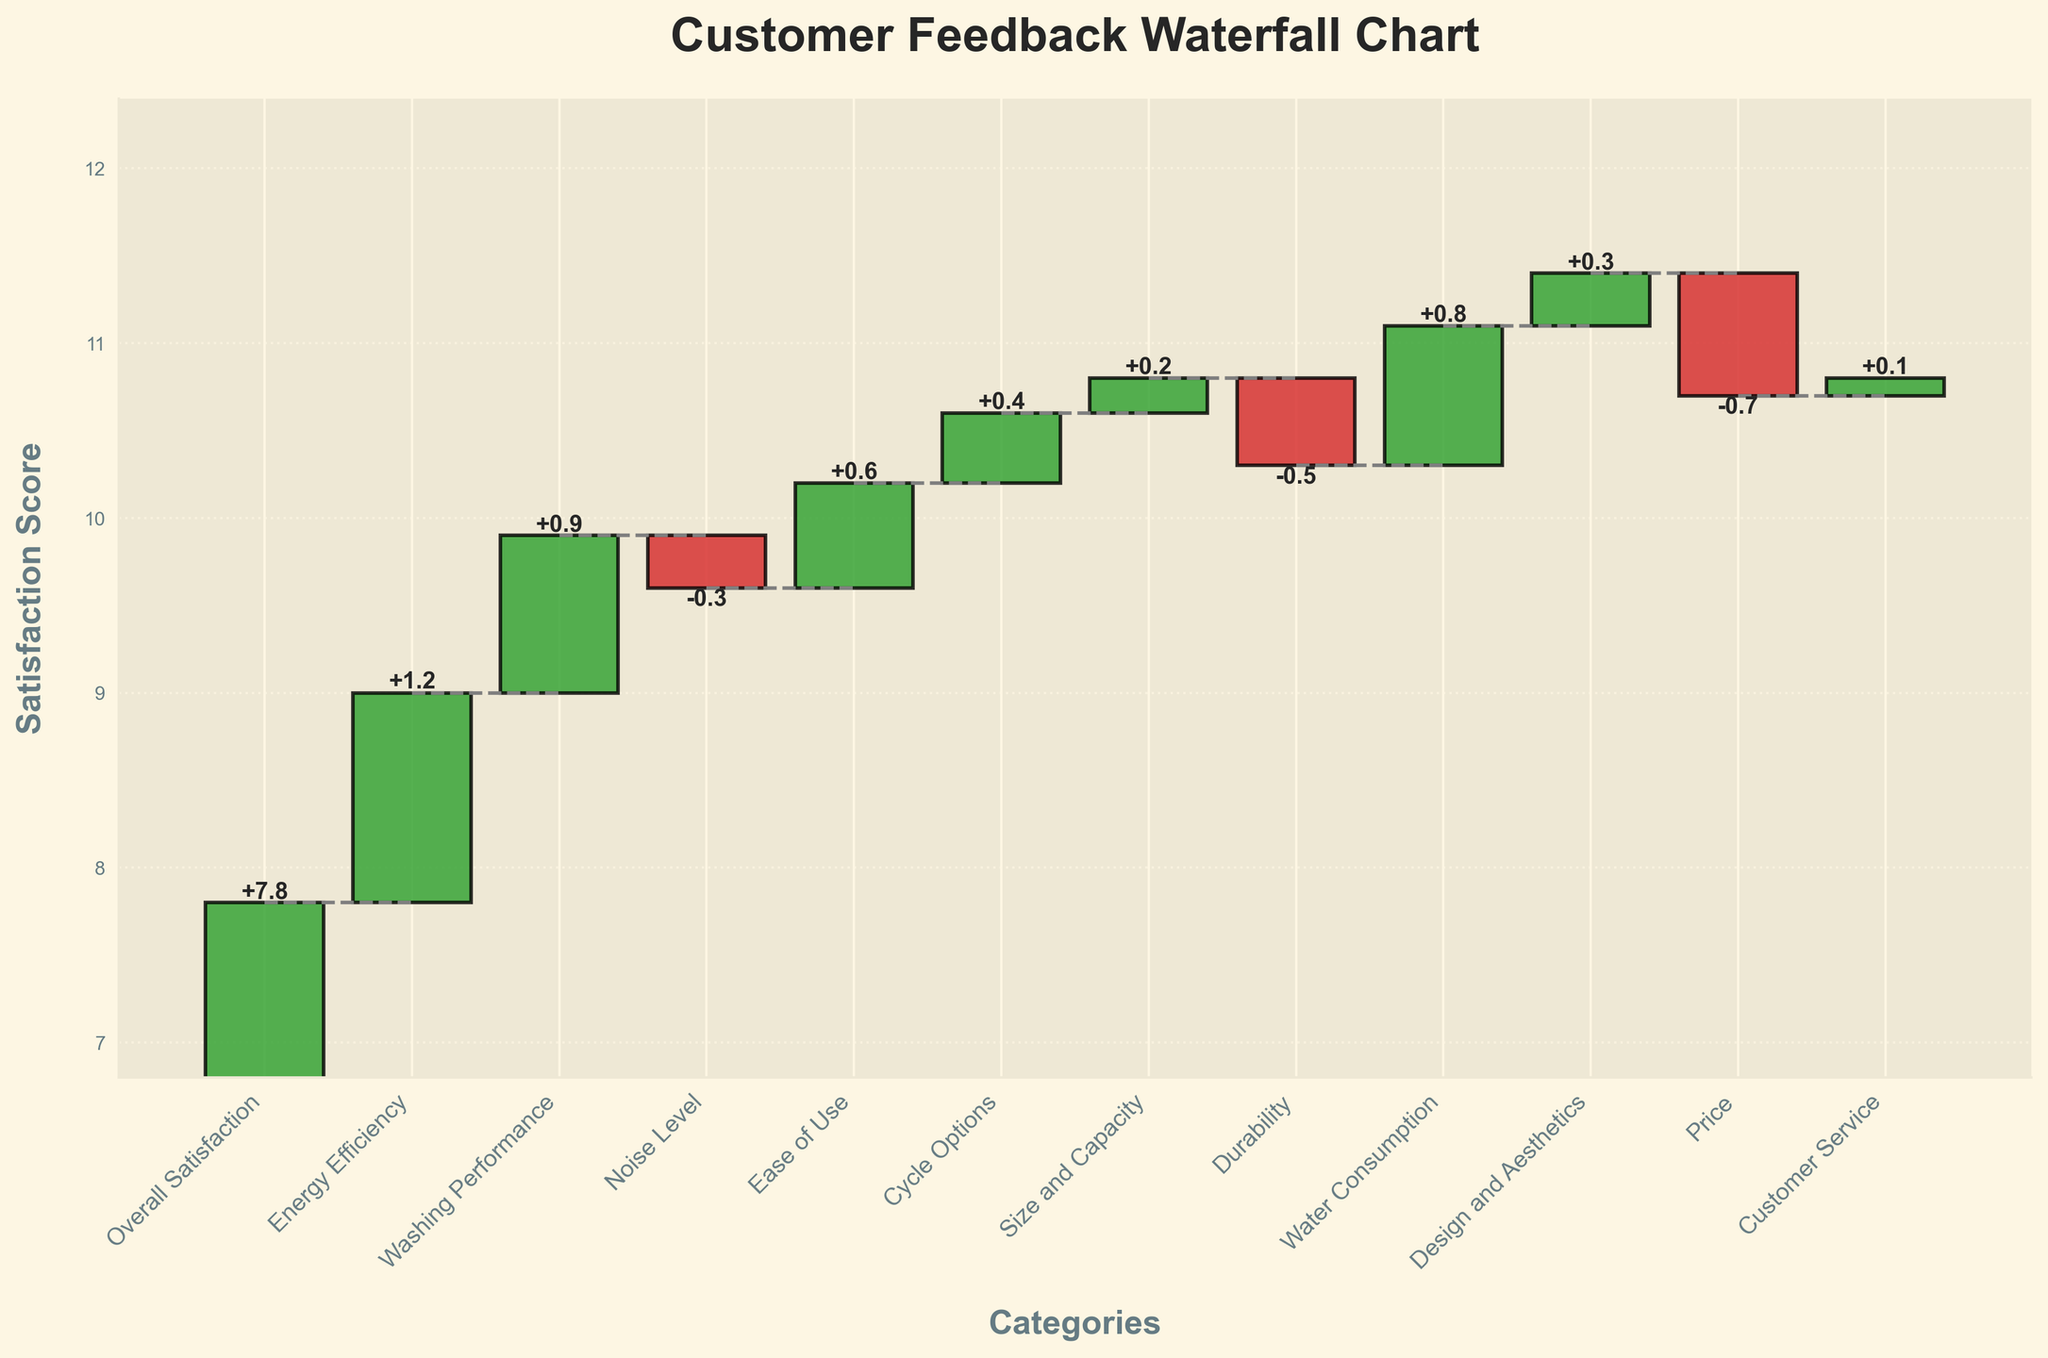What is the title of the chart? The title of the chart is prominently displayed at the top and reads "Customer Feedback Waterfall Chart".
Answer: Customer Feedback Waterfall Chart Which category has the highest positive contribution to overall satisfaction? In the chart, the bar with the highest positive value is the one corresponding to "Energy Efficiency".
Answer: Energy Efficiency Which category negatively impacts the overall satisfaction the most? The category with the longest negative bar, indicating the largest negative impact, is "Price".
Answer: Price How does the "Noise Level" category affect the overall satisfaction score? The bar for "Noise Level" is below the x-axis, which means it has a negative contribution to the overall satisfaction score.
Answer: It negatively affects the score What is the final cumulative satisfaction score after adding all the categories? The cumulative satisfaction score after integrating all category values is indicated at the top of the final bar, and it reads 7.8.
Answer: 7.8 Combine the effects of "Energy Efficiency" and "Washing Performance". What is the total contribution to the overall satisfaction? "Energy Efficiency" contributes +1.2 and "Washing Performance" contributes +0.9. Adding these together gives 1.2 + 0.9 = 2.1.
Answer: 2.1 Compare the contributions of "Durability" and "Design and Aesthetics". Which one contributes more positively to satisfaction? "Design and Aesthetics" has a positive value (+0.3), while "Durability" has a negative value (-0.5), which means "Design and Aesthetics" contributes more positively.
Answer: Design and Aesthetics What is the total positive contribution to satisfaction from all the categories combined? Sum up all positive values: Energy Efficiency (+1.2), Washing Performance (+0.9), Ease of Use (+0.6), Cycle Options (+0.4), Size and Capacity (+0.2), Water Consumption (+0.8), Design and Aesthetics (+0.3), Customer Service (+0.1). The total is 1.2 + 0.9 + 0.6 + 0.4 + 0.2 + 0.8 + 0.3 + 0.1 = 4.5.
Answer: 4.5 What is the net effect of "Noise Level" and "Durability" on the overall satisfaction score? "Noise Level" has a value of -0.3 and "Durability" has a value of -0.5. Adding these gives -0.3 + (-0.5) = -0.8.
Answer: -0.8 